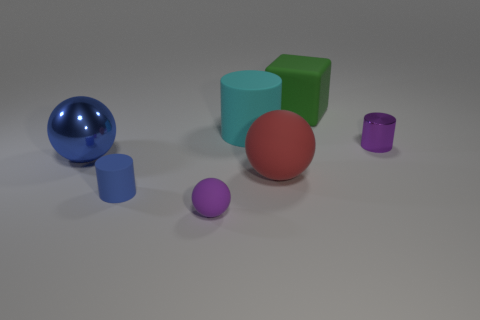Subtract all tiny metal cylinders. How many cylinders are left? 2 Add 3 cyan rubber cylinders. How many objects exist? 10 Subtract all blue cylinders. How many cylinders are left? 2 Subtract all cubes. How many objects are left? 6 Subtract 1 cylinders. How many cylinders are left? 2 Add 2 blue matte objects. How many blue matte objects are left? 3 Add 6 red metallic cylinders. How many red metallic cylinders exist? 6 Subtract 0 red blocks. How many objects are left? 7 Subtract all yellow blocks. Subtract all red cylinders. How many blocks are left? 1 Subtract all metallic things. Subtract all rubber cylinders. How many objects are left? 3 